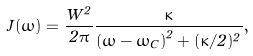Convert formula to latex. <formula><loc_0><loc_0><loc_500><loc_500>J ( \omega ) = \frac { W ^ { 2 } } { 2 \pi } \frac { \kappa } { \left ( \omega - \omega _ { C } \right ) ^ { 2 } + ( \kappa / 2 ) ^ { 2 } } ,</formula> 